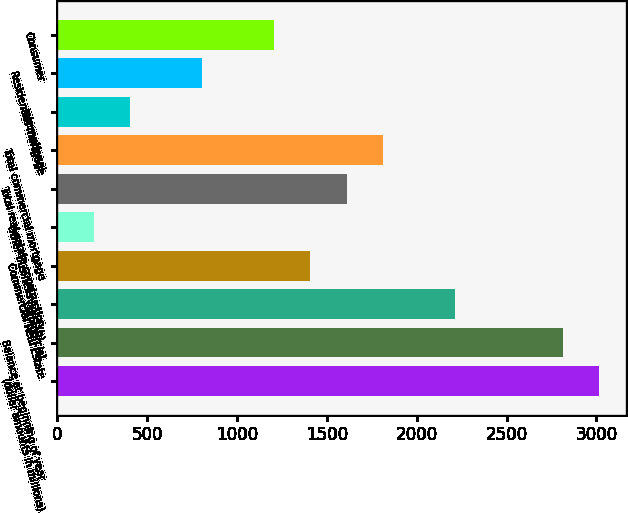Convert chart to OTSL. <chart><loc_0><loc_0><loc_500><loc_500><bar_chart><fcel>(dollar amounts in millions)<fcel>Balance at beginning of year<fcel>Commercial<fcel>Commercial Real Estate<fcel>Other business lines (b)<fcel>Total real estate construction<fcel>Total commercial mortgage<fcel>International<fcel>Residential mortgage<fcel>Consumer<nl><fcel>3016.12<fcel>2815.1<fcel>2212.04<fcel>1407.96<fcel>201.84<fcel>1608.98<fcel>1810<fcel>402.86<fcel>804.9<fcel>1206.94<nl></chart> 